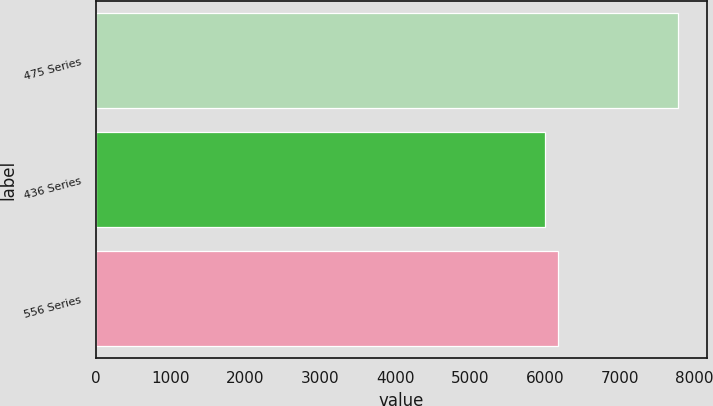Convert chart to OTSL. <chart><loc_0><loc_0><loc_500><loc_500><bar_chart><fcel>475 Series<fcel>436 Series<fcel>556 Series<nl><fcel>7780<fcel>6000<fcel>6178<nl></chart> 